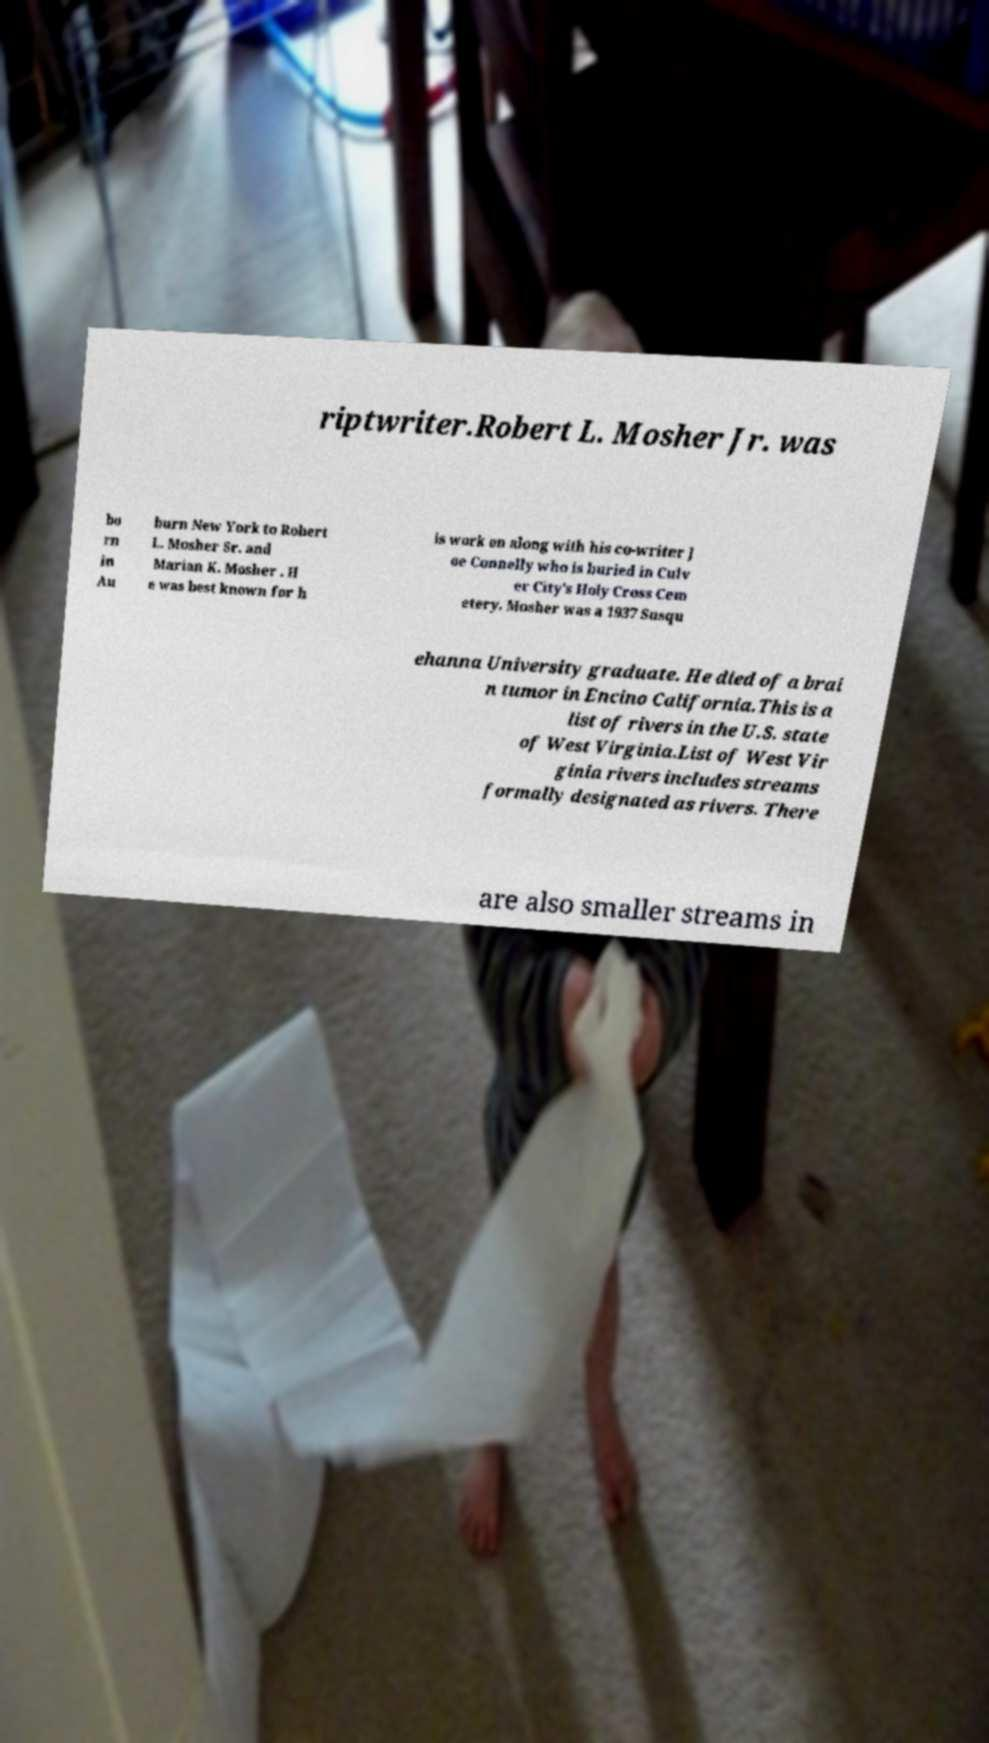Please identify and transcribe the text found in this image. riptwriter.Robert L. Mosher Jr. was bo rn in Au burn New York to Robert L. Mosher Sr. and Marian K. Mosher . H e was best known for h is work on along with his co-writer J oe Connelly who is buried in Culv er City's Holy Cross Cem etery. Mosher was a 1937 Susqu ehanna University graduate. He died of a brai n tumor in Encino California.This is a list of rivers in the U.S. state of West Virginia.List of West Vir ginia rivers includes streams formally designated as rivers. There are also smaller streams in 